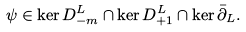<formula> <loc_0><loc_0><loc_500><loc_500>\psi \in \ker D _ { - m } ^ { L } \cap \ker D _ { + 1 } ^ { L } \cap \ker \bar { \partial } _ { L } .</formula> 